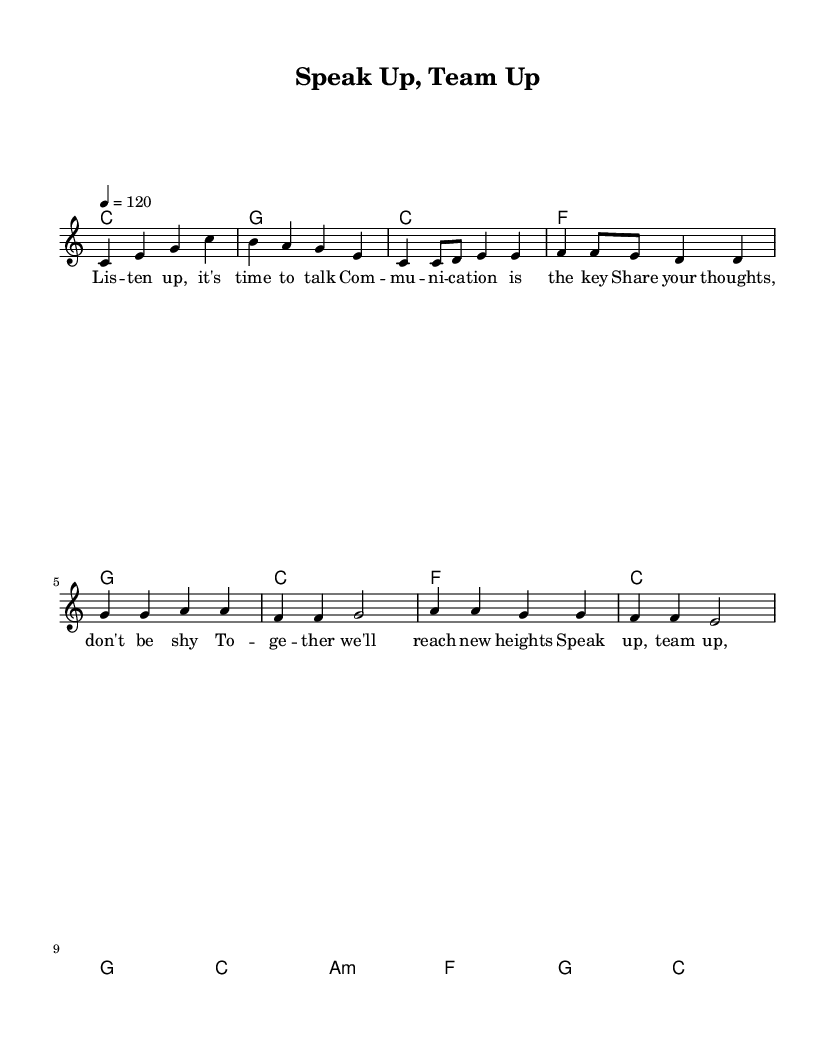What is the key signature of this music? The key signature is C major, which has no sharps or flats indicated in the music sheet.
Answer: C major What is the time signature of this music? The time signature shown is 4/4, which means there are four beats in a measure and a quarter note receives one beat.
Answer: 4/4 What is the tempo of this piece? The tempo marking indicates a speed of 120 beats per minute, which is notated at the beginning of the score.
Answer: 120 How many measures are in the chorus? The chorus consists of four measures, which can be counted from the music sheet where the chorus lyrics are aligned with the staff music.
Answer: 4 What is the first lyric line of the verse? The first lyric line of the verse is "Listen up, it's time to talk," and can be found visually at the start of the verse section in the lyric stanza.
Answer: Listen up, it's time to talk What chord follows the first measure of the chorus? The first chord following the initial measure of the chorus is F major, as indicated in the chord notation directly above the staff.
Answer: F What musical element is emphasized for teamwork in the song? The repeated phrase "Speak up, team up," emphasizes the importance of communication and collaboration, clearly noted in the chorus.
Answer: Speak up, team up 